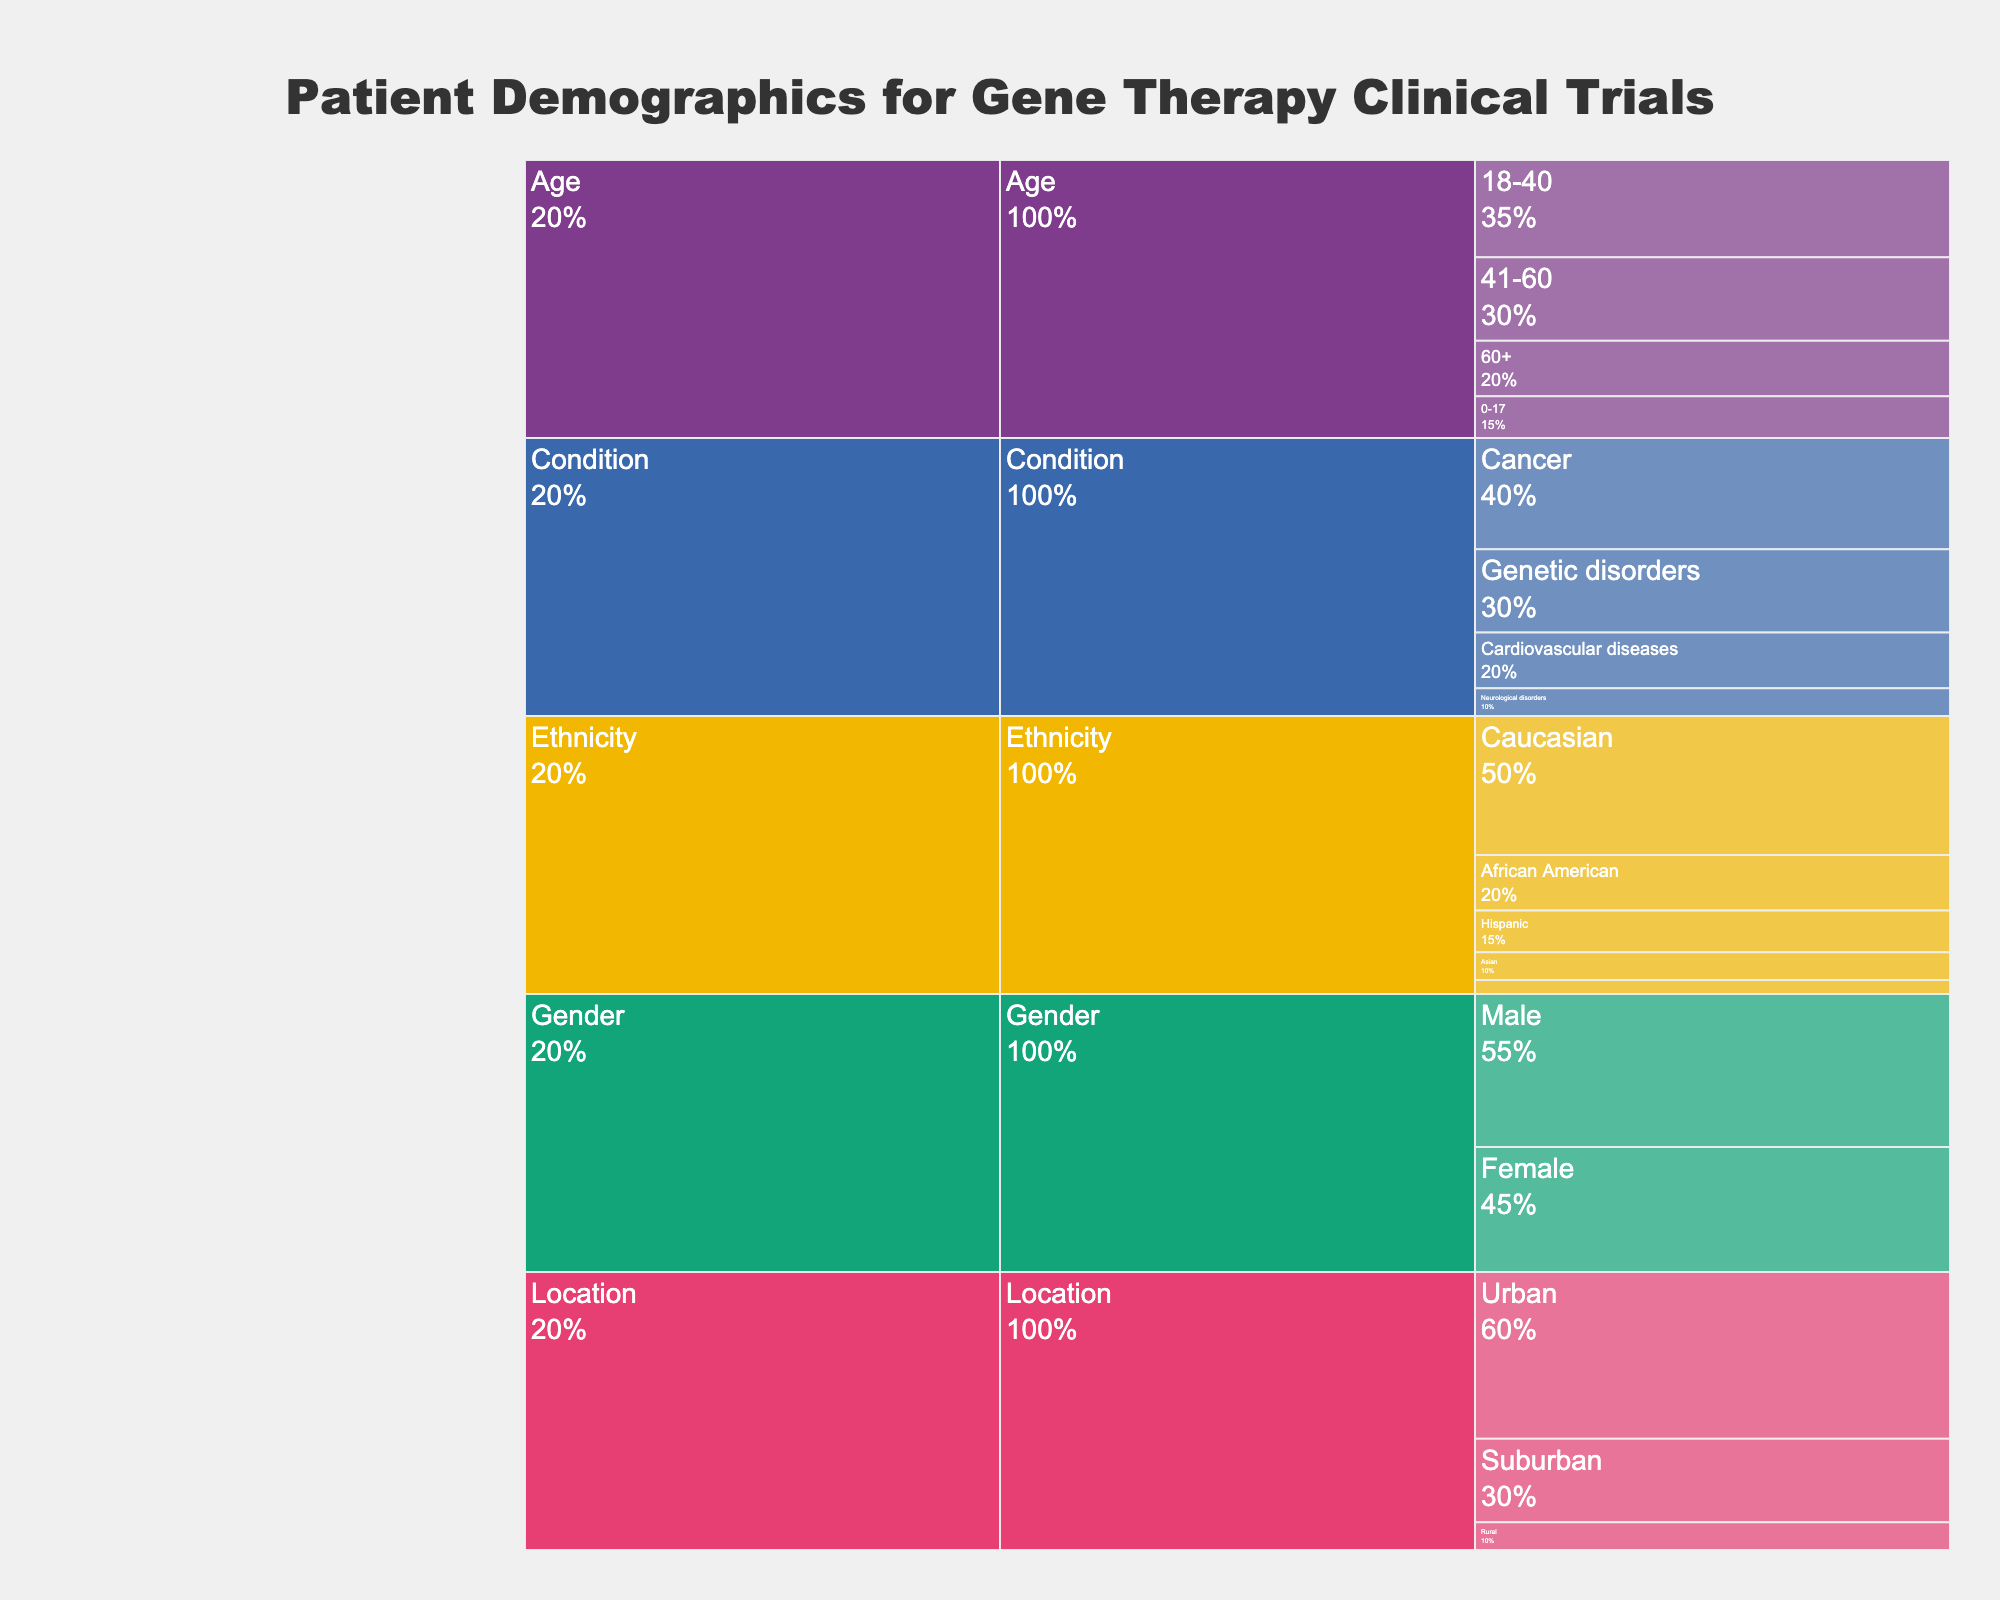What's the total number of patients aged 18-40 and 41-60? Sum the values for both age groups. For 18-40: 35, and for 41-60: 30. So, 35 + 30 = 65
Answer: 65 Which gender has the higher number of patients? Compare the values for Male (55) and Female (45). Male has a higher number.
Answer: Male What percentage of patients have cancer compared to the total number of patients by condition? The value for Cancer is 40. The total for all conditions is 40 + 30 + 20 + 10 = 100. So, 40/100 = 0.4 or 40%
Answer: 40% Which ethnicity has the lowest representation? Compare the values for all ethnicities. 'Other' has the lowest value of 5.
Answer: Other How many more patients are from urban areas compared to rural areas? Urban has 60 patients, and Rural has 10. The difference is 60 - 10 = 50.
Answer: 50 What is the total number of patients in the chart? Sum the values for all categories. Age (15 + 35 + 30 + 20 = 100), Gender (55 + 45 = 100), Condition (40 + 30 + 20 + 10 = 100), Ethnicity (50 + 20 + 15 + 10 + 5 = 100), and Location (60 + 30 + 10 = 100). The total is 100 for each category, but there's overlap, so individual item summation isn't required here. Each top-level category sums to 100.
Answer: 100 What is the most common condition among patients? Look at the values for different conditions. Cancer has the highest value at 40.
Answer: Cancer How does the percentage of patients aged 0-17 compare to those aged 60+? Patients aged 0-17: 15/100 = 15%. Patients aged 60+: 20/100 = 20%. 15% vs. 20%, aged 60+ has a higher percentage.
Answer: They represent 15% and 20%, respectively What's the distribution of patients from suburban areas? The value for Suburban is 30. From a total of 100 (under Location category), this is 30/100 = 0.3 or 30%.
Answer: 30% Which category has the most diverse subcategories? Count the subcategories under each category. Ethnicity has 5 subcategories (Caucasian, African American, Hispanic, Asian, Other).
Answer: Ethnicity 